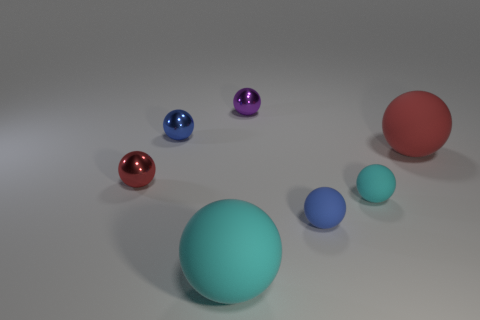Subtract all small spheres. How many spheres are left? 2 Subtract all cyan spheres. How many spheres are left? 5 Add 1 big cyan spheres. How many objects exist? 8 Subtract all blue spheres. Subtract all yellow blocks. How many spheres are left? 5 Add 1 cylinders. How many cylinders exist? 1 Subtract 2 cyan balls. How many objects are left? 5 Subtract all small cyan things. Subtract all small purple balls. How many objects are left? 5 Add 3 tiny things. How many tiny things are left? 8 